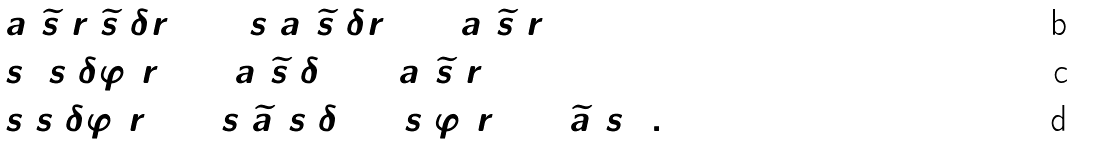<formula> <loc_0><loc_0><loc_500><loc_500>& a ( \widetilde { s } _ { 1 } r _ { 1 } \widetilde { s } _ { 2 } \delta r _ { 2 } ) = s _ { 1 } a ( \widetilde { s } _ { 2 } \delta r _ { 2 } ) + a ( \widetilde { s } _ { 1 } r _ { 1 } ) \\ = \, & s _ { 1 } [ s _ { 2 } \delta \varphi ( r _ { 2 } ) + a ( \widetilde { s } _ { 2 } \delta ) ] + a ( \widetilde { s } _ { 1 } r _ { 1 } ) \\ = \, & s _ { 1 } s _ { 2 } \delta \varphi ( r _ { 2 } ) + s _ { 1 } \widetilde { a } ( s _ { 2 } \delta ) + s _ { 1 } \varphi ( r _ { 1 } ) + \widetilde { a } ( s _ { 1 } ) .</formula> 